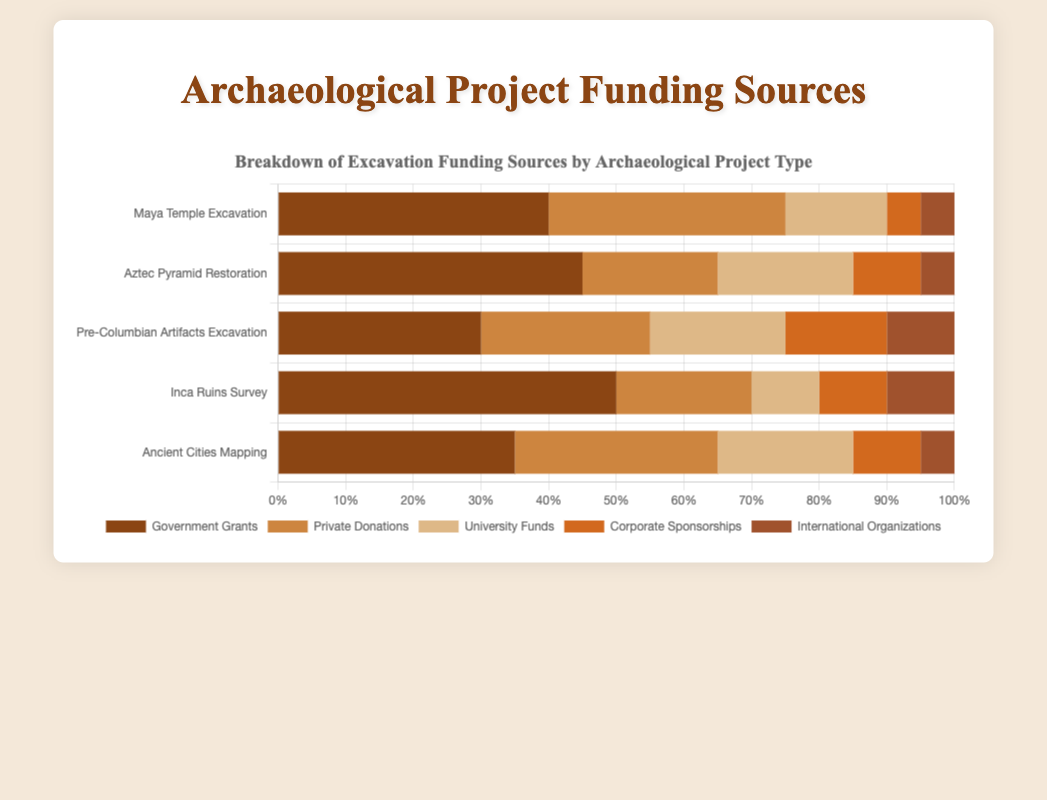How does the proportion of Government Grants compare between the Maya Temple Excavation and the Aztec Pyramid Restoration projects? To compare the proportion of Government Grants between "Maya Temple Excavation" and "Aztec Pyramid Restoration," we look at their respective values. Maya Temple Excavation has 40% Government Grants, while Aztec Pyramid Restoration has 45%.
Answer: Aztec Pyramid Restoration has more Government Grants Which archaeological project type has the highest percentage of Corporate Sponsorships? We compare the percentages for Corporate Sponsorships across all project types. Maya Temple Excavation has 5%, Aztec Pyramid Restoration has 10%, Pre-Columbian Artifacts Excavation has 15%, Inca Ruins Survey has 10%, and Ancient Cities Mapping has 10%. The highest value is for Pre-Columbian Artifacts Excavation with 15%.
Answer: Pre-Columbian Artifacts Excavation What is the sum of the percentages of Private Donations and University Funds for the Inca Ruins Survey project? The percentages for Private Donations and University Funds in the Inca Ruins Survey are 20% and 10% respectively. Adding these together gives 20% + 10% = 30%.
Answer: 30% Which project type receives the least funding from International Organizations, and what is the amount? We review the International Organizations funding for each project: Maya Temple Excavation has 5%, Aztec Pyramid Restoration has 5%, Pre-Columbian Artifacts Excavation has 10%, Inca Ruins Survey has 10%, and Ancient Cities Mapping has 5%. The minimum values are for Maya Temple Excavation, Aztec Pyramid Restoration, and Ancient Cities Mapping, each with 5%.
Answer: Maya Temple Excavation, Aztec Pyramid Restoration, Ancient Cities Mapping - 5% Does any project type receive equal funding from Private Donations and University Funds? If yes, which one? We compare the percentages for Private Donations and University Funds across each project type. For "Aztec Pyramid Restoration," both Private Donations and University Funds are 20%.
Answer: Yes, Aztec Pyramid Restoration What is the total funding from Corporate Sponsorships and International Organizations for the Ancient Cities Mapping project? For Ancient Cities Mapping, Corporate Sponsorships is 10% and International Organizations is 5%. Adding these together gives 10% + 5% = 15%.
Answer: 15% Which project type has the highest overall funding percentage from Government Grants? We compare the Government Grants percentages: Maya Temple Excavation (40%), Aztec Pyramid Restoration (45%), Pre-Columbian Artifacts Excavation (30%), Inca Ruins Survey (50%), Ancient Cities Mapping (35%). The highest is Inca Ruins Survey with 50%.
Answer: Inca Ruins Survey Compare the sum of Private Donations and University Funds for the Maya Temple Excavation and the Pre-Columbian Artifacts Excavation. Which project has a higher sum? For Maya Temple Excavation, the sum of Private Donations (35%) and University Funds (15%) is 35% + 15% = 50%. For Pre-Columbian Artifacts Excavation, the sum is Private Donations (25%) + University Funds (20%) = 45%. Thus, Maya Temple Excavation has a higher sum.
Answer: Maya Temple Excavation 